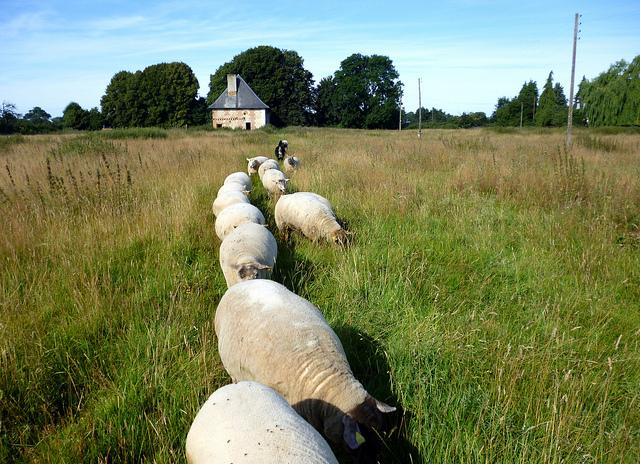Where are the power lines?
Quick response, please. Background. Are the animals in the wild or captivity?
Keep it brief. Captivity. How many lambs?
Write a very short answer. 10. How many buildings are in the background?
Short answer required. 1. 